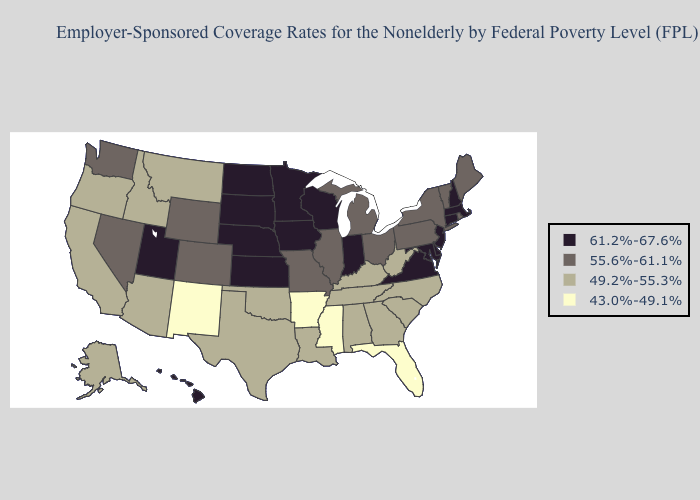Does Georgia have the lowest value in the South?
Write a very short answer. No. Name the states that have a value in the range 61.2%-67.6%?
Quick response, please. Connecticut, Delaware, Hawaii, Indiana, Iowa, Kansas, Maryland, Massachusetts, Minnesota, Nebraska, New Hampshire, New Jersey, North Dakota, South Dakota, Utah, Virginia, Wisconsin. Does Missouri have the highest value in the USA?
Concise answer only. No. Does New Jersey have the lowest value in the Northeast?
Keep it brief. No. What is the lowest value in states that border Vermont?
Short answer required. 55.6%-61.1%. Does Missouri have the highest value in the MidWest?
Answer briefly. No. What is the value of Maryland?
Give a very brief answer. 61.2%-67.6%. Does Michigan have a lower value than Virginia?
Keep it brief. Yes. Which states hav the highest value in the Northeast?
Answer briefly. Connecticut, Massachusetts, New Hampshire, New Jersey. What is the value of Georgia?
Keep it brief. 49.2%-55.3%. Does Vermont have the highest value in the USA?
Be succinct. No. What is the highest value in states that border Connecticut?
Short answer required. 61.2%-67.6%. What is the value of Colorado?
Short answer required. 55.6%-61.1%. Which states have the highest value in the USA?
Quick response, please. Connecticut, Delaware, Hawaii, Indiana, Iowa, Kansas, Maryland, Massachusetts, Minnesota, Nebraska, New Hampshire, New Jersey, North Dakota, South Dakota, Utah, Virginia, Wisconsin. What is the value of Rhode Island?
Keep it brief. 55.6%-61.1%. 